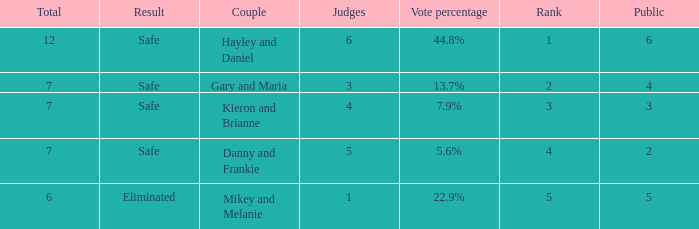What was the total number when the vote percentage was 44.8%? 1.0. 